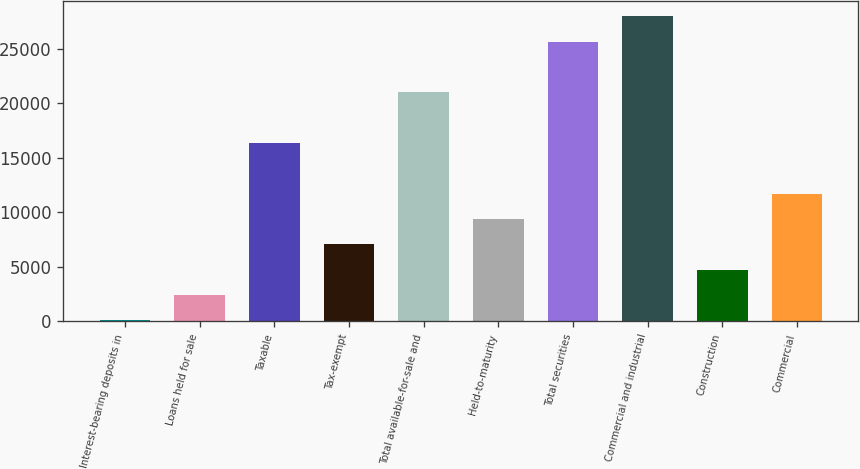Convert chart. <chart><loc_0><loc_0><loc_500><loc_500><bar_chart><fcel>Interest-bearing deposits in<fcel>Loans held for sale<fcel>Taxable<fcel>Tax-exempt<fcel>Total available-for-sale and<fcel>Held-to-maturity<fcel>Total securities<fcel>Commercial and industrial<fcel>Construction<fcel>Commercial<nl><fcel>85<fcel>2410.6<fcel>16364.2<fcel>7061.8<fcel>21015.4<fcel>9387.4<fcel>25666.6<fcel>27992.2<fcel>4736.2<fcel>11713<nl></chart> 